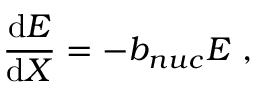Convert formula to latex. <formula><loc_0><loc_0><loc_500><loc_500>\frac { d E } { d X } = - b _ { n u c } E ,</formula> 